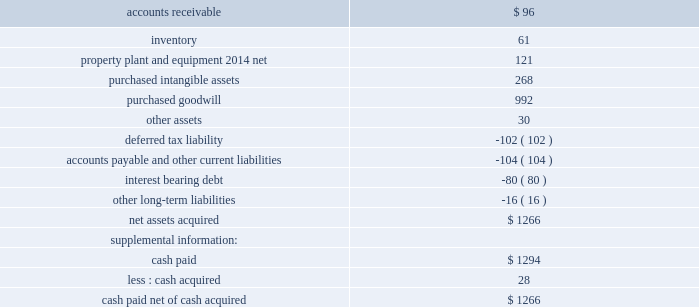The 2006 impact on the consolidated balance sheet of the purchase price allocations related to the 2006 acquisitions and adjustments relative to other acquisitions within the allocation period were provided in the preceding table .
Year 2005 acquisitions : the company acquired cuno on august 2 , 2005 .
The operating results of cuno are included in the industrial and transportation business segment .
Cuno is engaged in the design , manufacture and marketing of a comprehensive line of filtration products for the separation , clarification and purification of fluids and gases .
3m and cuno have complementary sets of filtration technologies , creating an opportunity to bring an even wider range of filtration solutions to customers around the world .
3m acquired cuno for approximately $ 1.36 billion , comprised of $ 1.27 billion of cash paid ( net of cash acquired ) and the acquisition of $ 80 million of debt , most of which has been repaid .
Purchased identifiable intangible assets of $ 268 million for the cuno acquisition will be amortized on a straight-line basis over lives ranging from 5 to 20 years ( weighted-average life of 15 years ) .
In-process research and development charges from the cuno acquisition were not material .
Pro forma information related to this acquisition is not included because its impact on the company 2019s consolidated results of operations is not considered to be material .
The allocation of the purchase price is presented in the table that follows .
2005 cuno acquisition asset ( liability ) ( millions ) .
During the year ended december 31 , 2005 , 3m entered into two immaterial additional business combinations for a total purchase price of $ 27 million , net of cash acquired .
1 ) 3m ( electro and communications business ) purchased certain assets of siemens ultrasound division 2019s flexible circuit manufacturing line , a u.s .
Operation .
The acquired operation produces flexible interconnect circuits that provide electrical connections between components in electronics systems used primarily in the transducers of ultrasound machines .
2 ) 3m ( display and graphics business ) purchased certain assets of mercury online solutions inc. , a u.s .
Operation .
The acquired operation provides hardware and software technologies and network management services for digital signage and interactive kiosk networks .
Note 3 .
Goodwill and intangible assets as discussed in note 16 to the consolidated financial statements , effective in the first quarter of 2007 , 3m made certain product moves between its business segments , which resulted in changes in the goodwill balances by business segment as presented below .
For those changes that resulted in reporting unit changes , the company applied the relative fair value method to determine the impact to reporting units .
Sfas no .
142 , 201cgoodwill and other intangible assets , 201d requires that goodwill be tested for impairment at least annually and when reporting units are changed .
Purchased goodwill from acquisitions totaled $ 326 million in 2007 , $ 55 million of which is deductible for tax purposes .
Purchased goodwill from acquisitions totaled $ 536 million in 2006 , $ 41 million of which is deductible for tax purposes. .
What was the percentage of the cash bought to total cash paid? 
Computations: (28 / 1294)
Answer: 0.02164. 